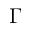Convert formula to latex. <formula><loc_0><loc_0><loc_500><loc_500>\Gamma</formula> 